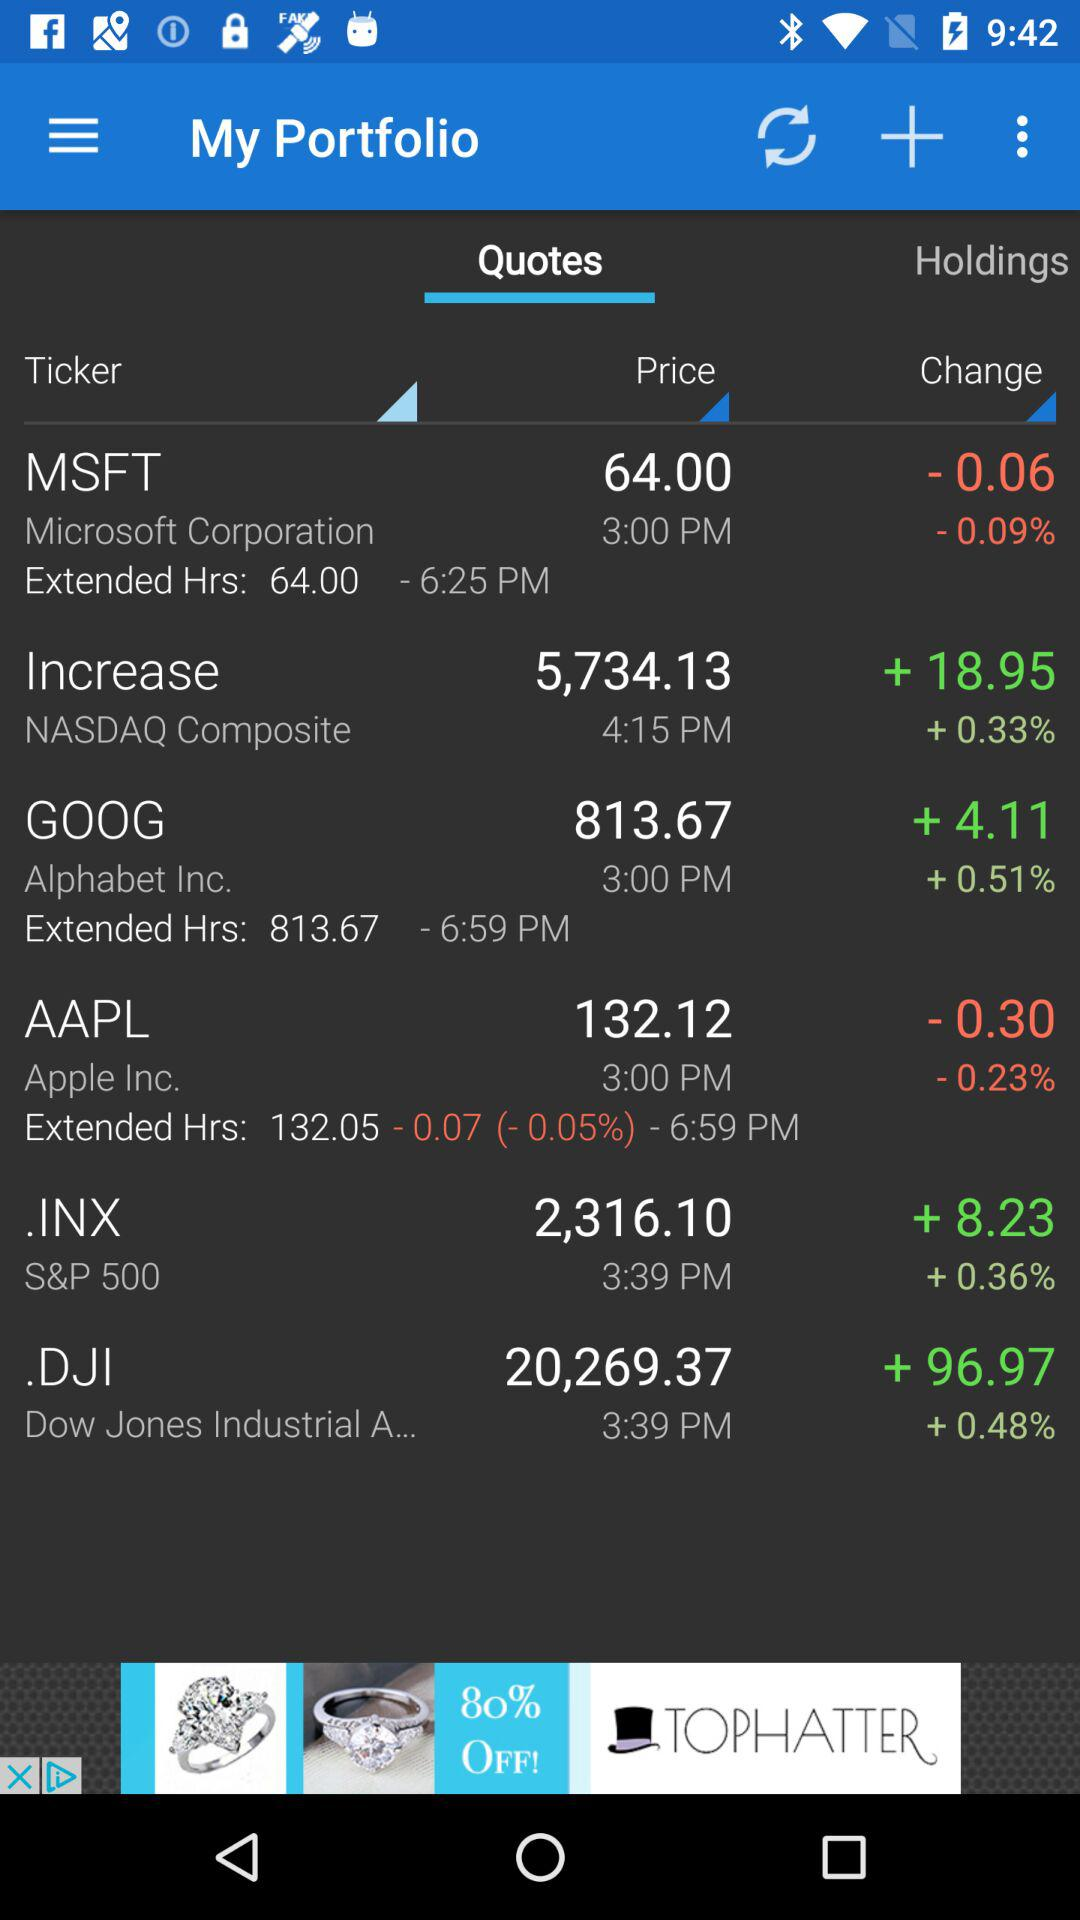What's the price of AAPL? The price of AAPL is 132.12. 